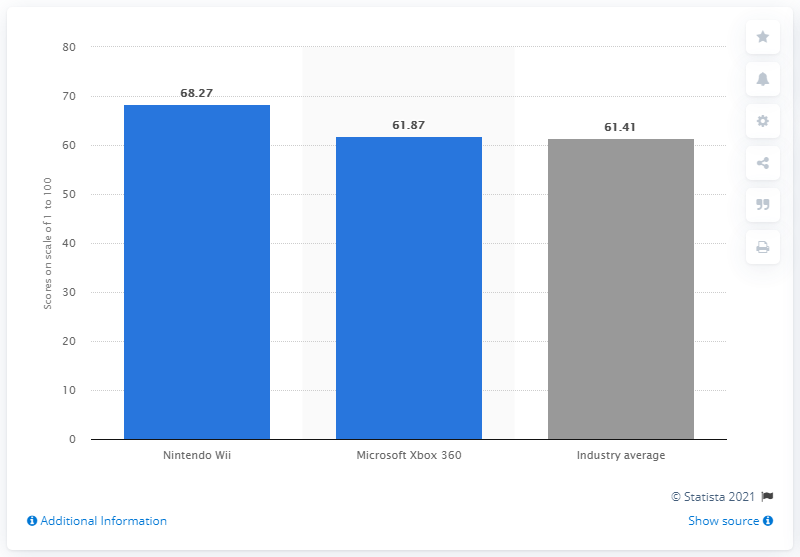What was Nintendo's equity score in 2012?
 68.27 